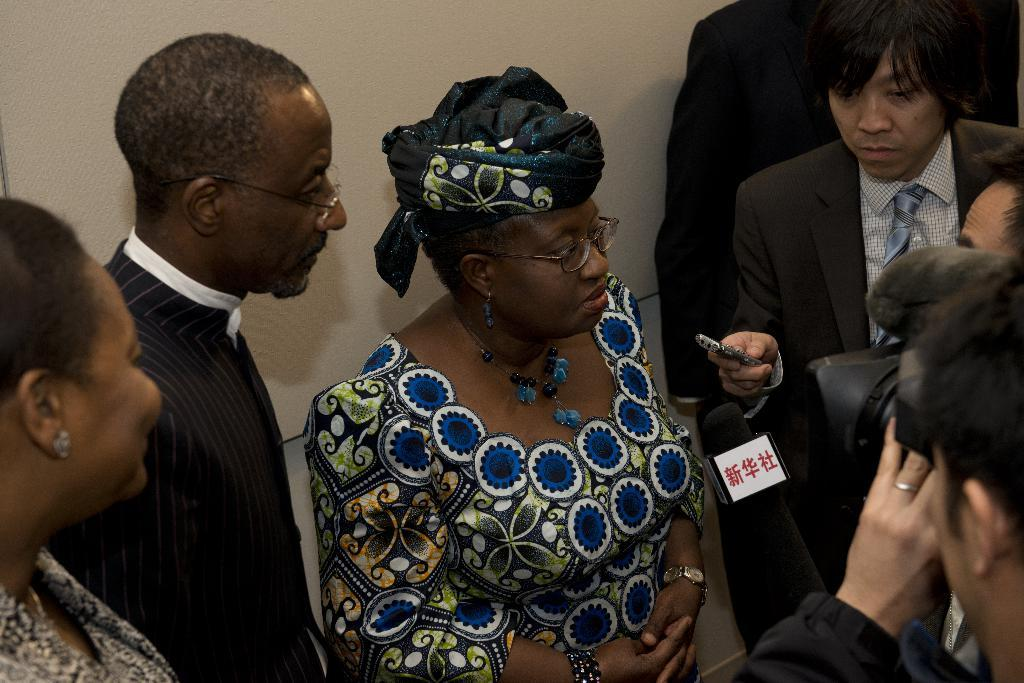How many people are in the image? There are persons in the image. What equipment is visible in the image? There is a camera and a microphone in the image. What can be seen in the background of the image? There is a wall in the background of the image. Can you see any jellyfish in the image? No, there are no jellyfish present in the image. Is there a stranger in the image? The facts provided do not mention a stranger, so we cannot determine if there is one in the image. 